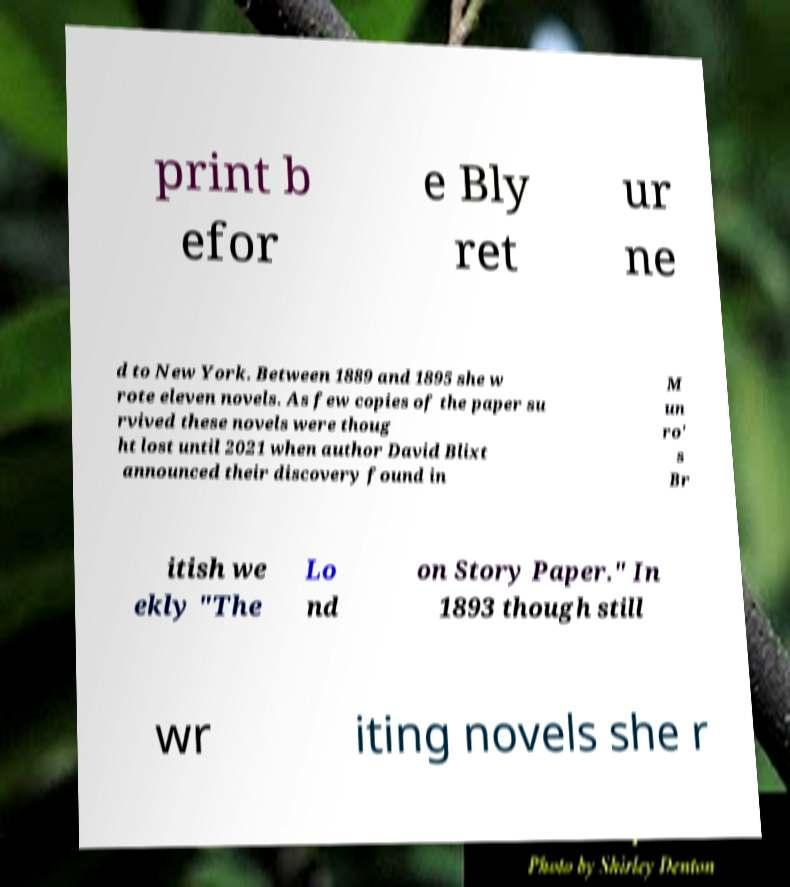Could you assist in decoding the text presented in this image and type it out clearly? print b efor e Bly ret ur ne d to New York. Between 1889 and 1895 she w rote eleven novels. As few copies of the paper su rvived these novels were thoug ht lost until 2021 when author David Blixt announced their discovery found in M un ro' s Br itish we ekly "The Lo nd on Story Paper." In 1893 though still wr iting novels she r 